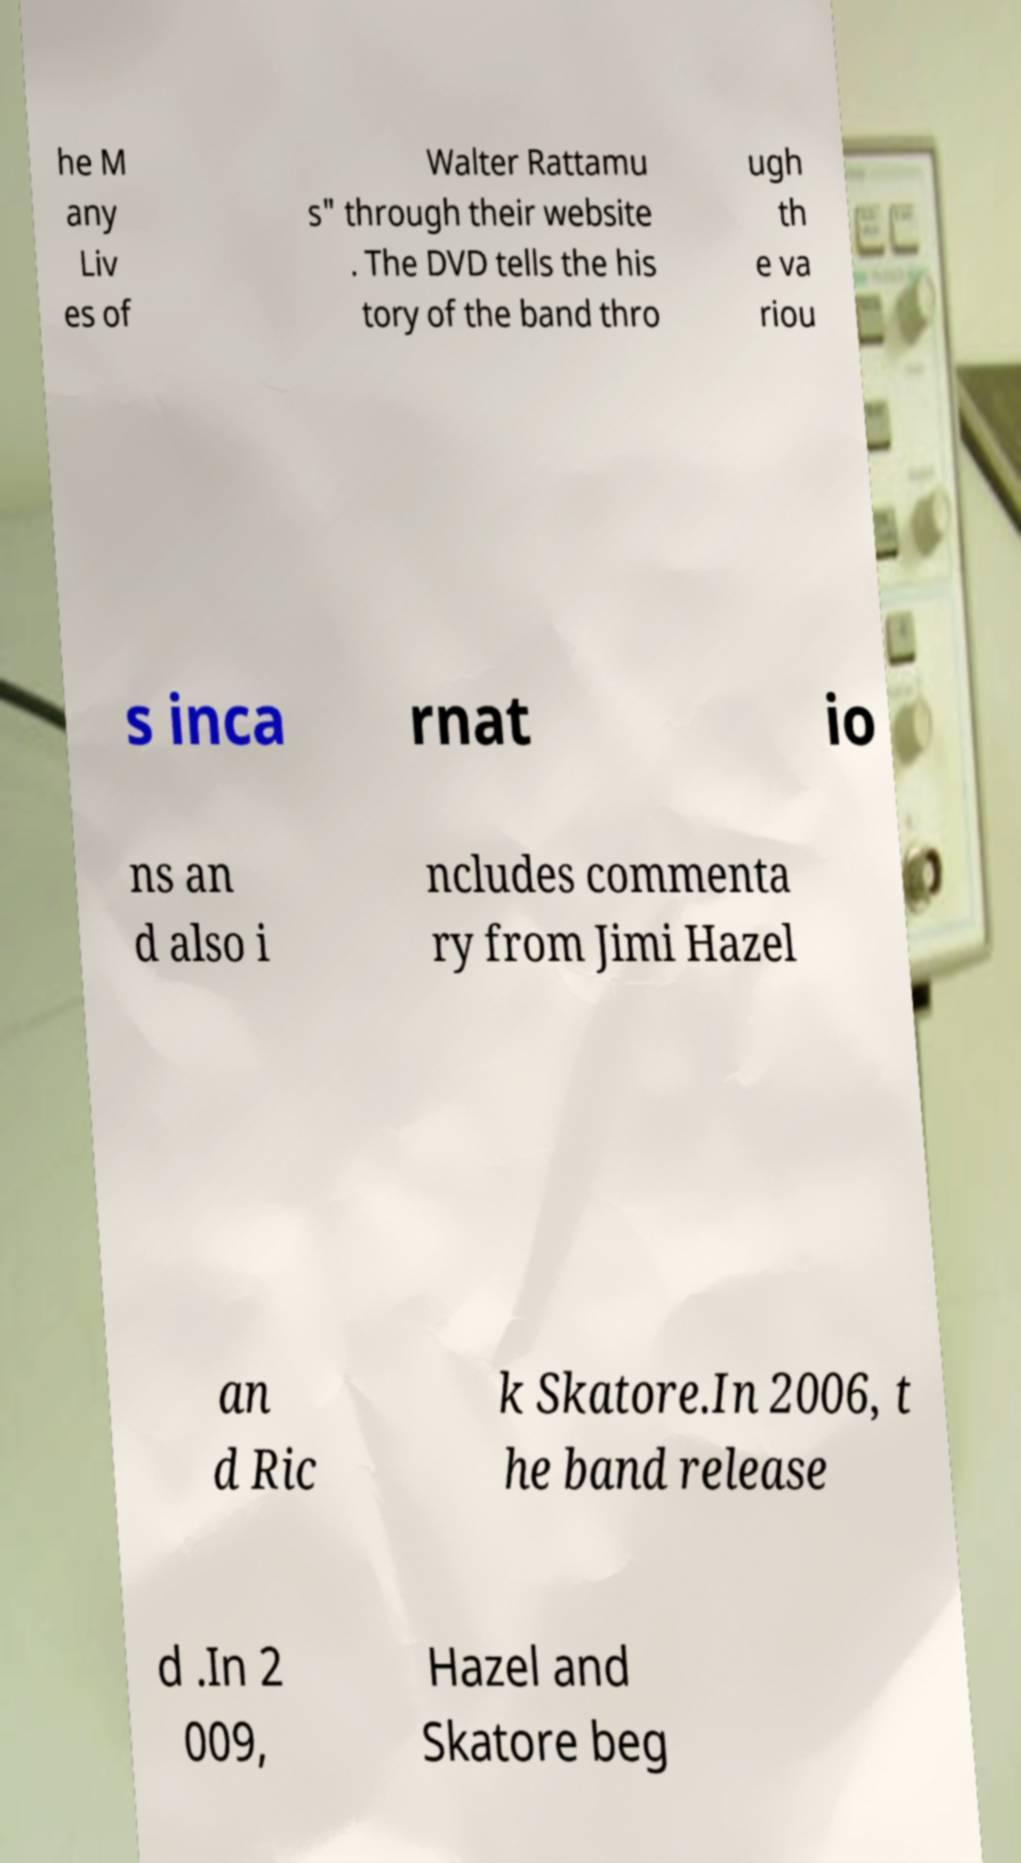I need the written content from this picture converted into text. Can you do that? he M any Liv es of Walter Rattamu s" through their website . The DVD tells the his tory of the band thro ugh th e va riou s inca rnat io ns an d also i ncludes commenta ry from Jimi Hazel an d Ric k Skatore.In 2006, t he band release d .In 2 009, Hazel and Skatore beg 